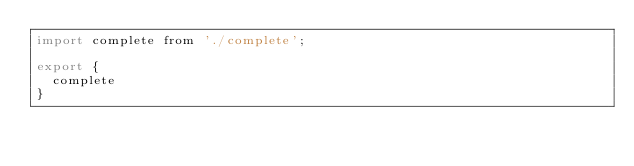Convert code to text. <code><loc_0><loc_0><loc_500><loc_500><_JavaScript_>import complete from './complete';

export {
  complete
}</code> 